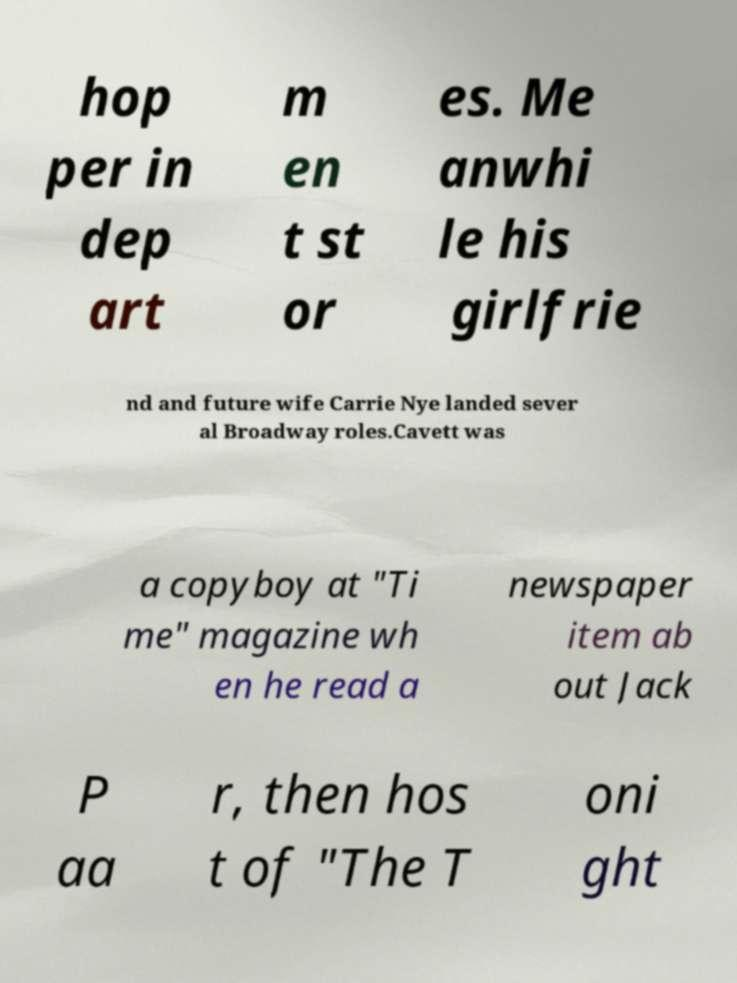For documentation purposes, I need the text within this image transcribed. Could you provide that? hop per in dep art m en t st or es. Me anwhi le his girlfrie nd and future wife Carrie Nye landed sever al Broadway roles.Cavett was a copyboy at "Ti me" magazine wh en he read a newspaper item ab out Jack P aa r, then hos t of "The T oni ght 